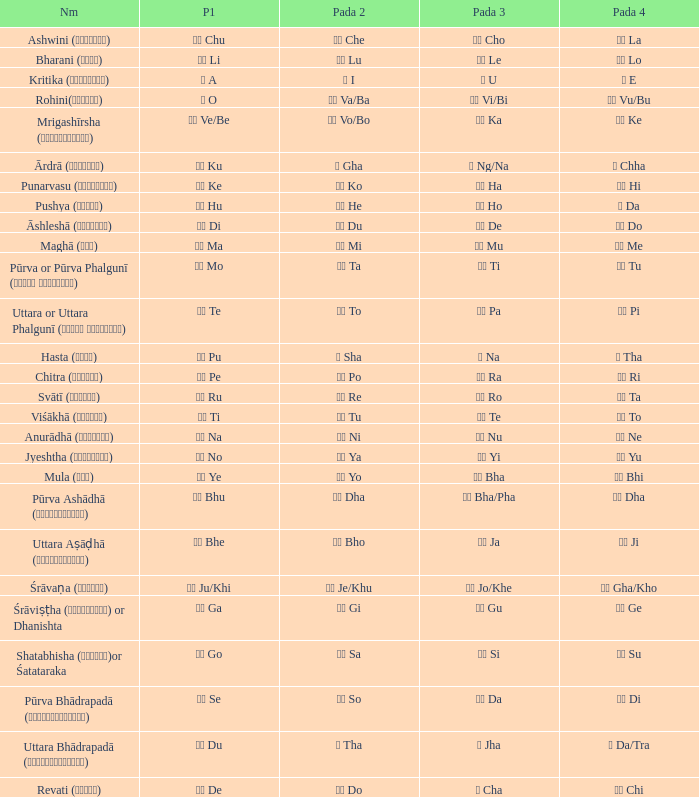Which Pada 3 has a Pada 1 of टे te? पा Pa. 